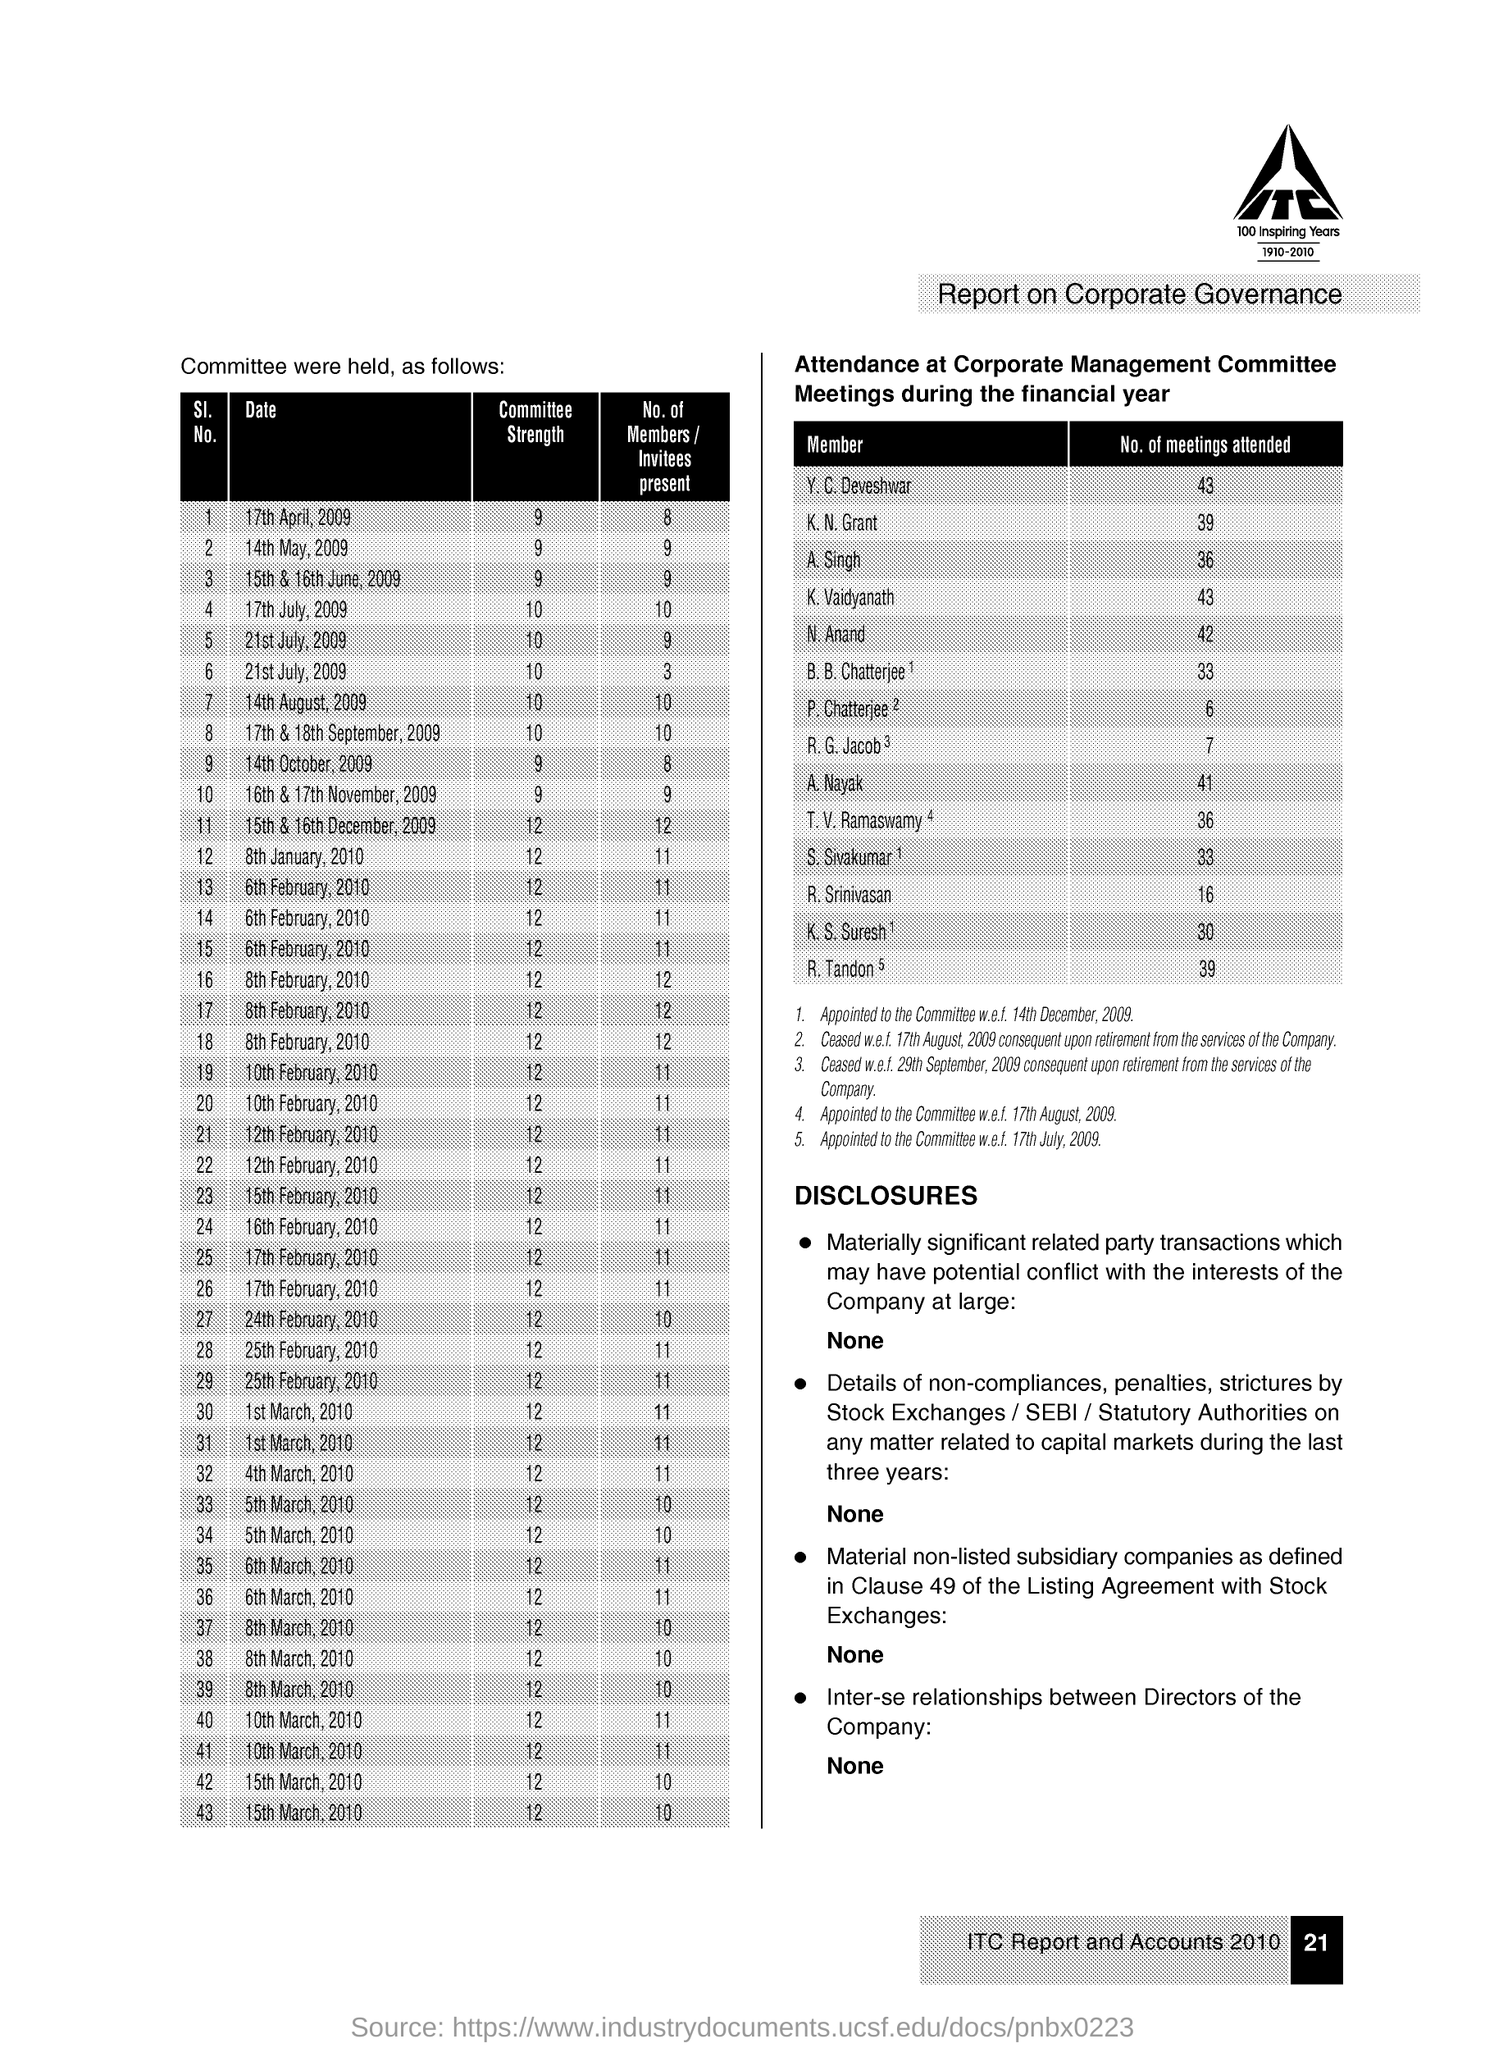What is the Committee Strength on 17th April, 2009?
Provide a succinct answer. 9. How many meetings have been attended by K. Vaidyanath?
Make the answer very short. 43. How many Members /Invitees were present on 17th July, 2009?
Provide a succinct answer. 10. 